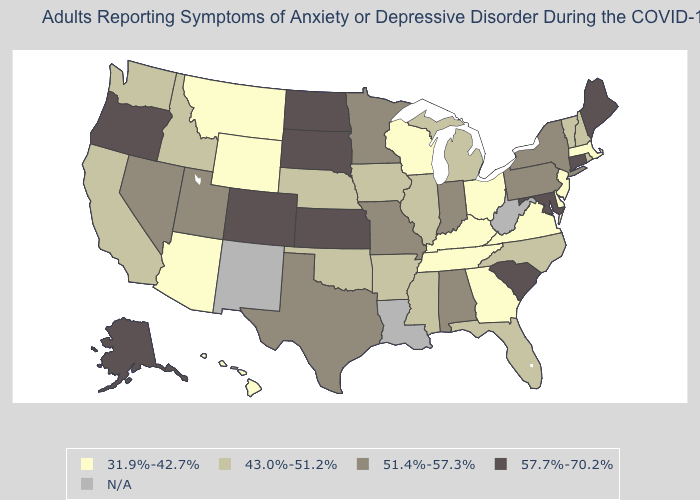What is the highest value in states that border North Dakota?
Keep it brief. 57.7%-70.2%. Name the states that have a value in the range 31.9%-42.7%?
Write a very short answer. Arizona, Delaware, Georgia, Hawaii, Kentucky, Massachusetts, Montana, New Jersey, Ohio, Tennessee, Virginia, Wisconsin, Wyoming. Name the states that have a value in the range 43.0%-51.2%?
Quick response, please. Arkansas, California, Florida, Idaho, Illinois, Iowa, Michigan, Mississippi, Nebraska, New Hampshire, North Carolina, Oklahoma, Rhode Island, Vermont, Washington. Does the map have missing data?
Answer briefly. Yes. Name the states that have a value in the range 57.7%-70.2%?
Quick response, please. Alaska, Colorado, Connecticut, Kansas, Maine, Maryland, North Dakota, Oregon, South Carolina, South Dakota. Name the states that have a value in the range 43.0%-51.2%?
Short answer required. Arkansas, California, Florida, Idaho, Illinois, Iowa, Michigan, Mississippi, Nebraska, New Hampshire, North Carolina, Oklahoma, Rhode Island, Vermont, Washington. Name the states that have a value in the range 57.7%-70.2%?
Short answer required. Alaska, Colorado, Connecticut, Kansas, Maine, Maryland, North Dakota, Oregon, South Carolina, South Dakota. Which states have the lowest value in the USA?
Write a very short answer. Arizona, Delaware, Georgia, Hawaii, Kentucky, Massachusetts, Montana, New Jersey, Ohio, Tennessee, Virginia, Wisconsin, Wyoming. How many symbols are there in the legend?
Give a very brief answer. 5. Does the map have missing data?
Write a very short answer. Yes. What is the value of Oklahoma?
Answer briefly. 43.0%-51.2%. What is the value of New Mexico?
Give a very brief answer. N/A. What is the value of Iowa?
Answer briefly. 43.0%-51.2%. Which states hav the highest value in the Northeast?
Short answer required. Connecticut, Maine. 